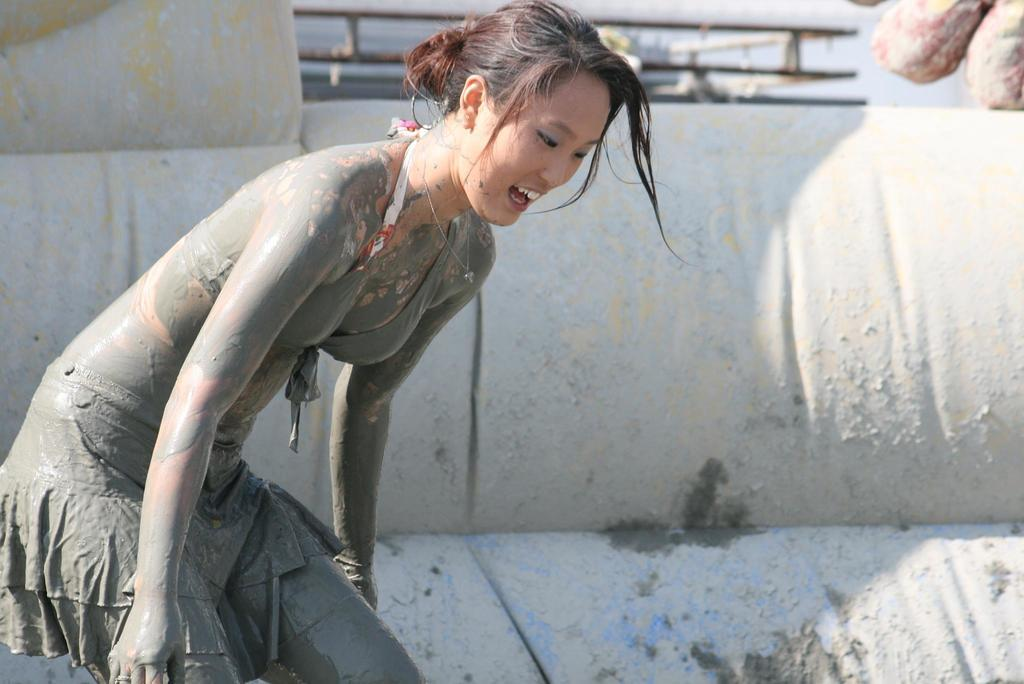Who is present in the image? There is a woman in the image. What is on the woman's body? Mud is on the woman's body. What can be seen in the background of the image? There is an inflatable object in the background of the image. What architectural feature is visible in the image? Beams are visible in the image. What type of trade is the woman participating in with her uncle in the image? There is no indication of any trade or uncle in the image; it only features a woman with mud on her body and an inflatable object in the background. 